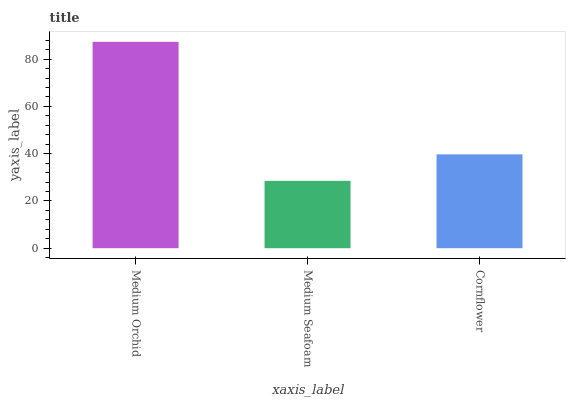Is Medium Seafoam the minimum?
Answer yes or no. Yes. Is Medium Orchid the maximum?
Answer yes or no. Yes. Is Cornflower the minimum?
Answer yes or no. No. Is Cornflower the maximum?
Answer yes or no. No. Is Cornflower greater than Medium Seafoam?
Answer yes or no. Yes. Is Medium Seafoam less than Cornflower?
Answer yes or no. Yes. Is Medium Seafoam greater than Cornflower?
Answer yes or no. No. Is Cornflower less than Medium Seafoam?
Answer yes or no. No. Is Cornflower the high median?
Answer yes or no. Yes. Is Cornflower the low median?
Answer yes or no. Yes. Is Medium Seafoam the high median?
Answer yes or no. No. Is Medium Orchid the low median?
Answer yes or no. No. 